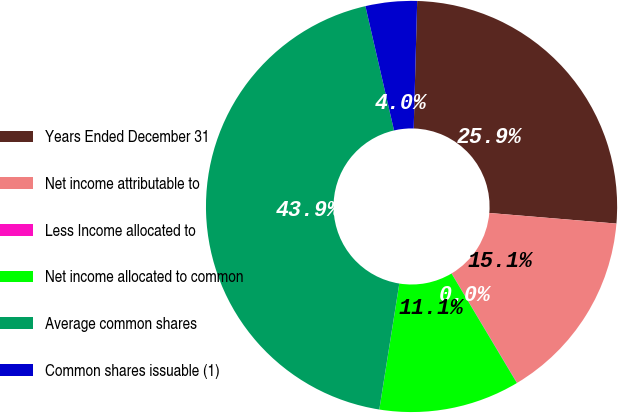Convert chart. <chart><loc_0><loc_0><loc_500><loc_500><pie_chart><fcel>Years Ended December 31<fcel>Net income attributable to<fcel>Less Income allocated to<fcel>Net income allocated to common<fcel>Average common shares<fcel>Common shares issuable (1)<nl><fcel>25.89%<fcel>15.08%<fcel>0.03%<fcel>11.07%<fcel>43.89%<fcel>4.04%<nl></chart> 